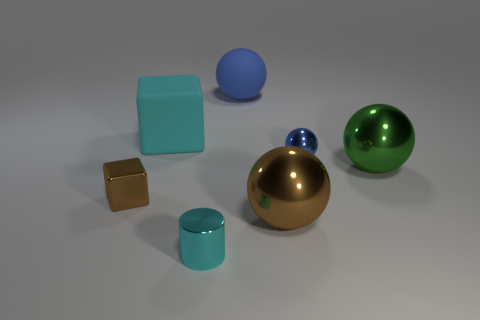Is the color of the cylinder the same as the small metal block?
Your answer should be compact. No. There is a small object that is both right of the big cube and to the left of the brown sphere; what is it made of?
Offer a very short reply. Metal. What color is the tiny metallic cube?
Give a very brief answer. Brown. How many small cyan things are the same shape as the large cyan matte object?
Provide a short and direct response. 0. Does the green ball behind the tiny cyan shiny cylinder have the same material as the tiny thing that is behind the large green sphere?
Make the answer very short. Yes. What size is the blue thing that is behind the big rubber object that is to the left of the big blue rubber sphere?
Provide a succinct answer. Large. Is there any other thing that has the same size as the blue metallic ball?
Keep it short and to the point. Yes. What material is the big green object that is the same shape as the small blue metallic thing?
Provide a short and direct response. Metal. There is a big blue object right of the small shiny cylinder; does it have the same shape as the cyan thing in front of the tiny blue metallic sphere?
Provide a succinct answer. No. Is the number of matte spheres greater than the number of big things?
Provide a short and direct response. No. 